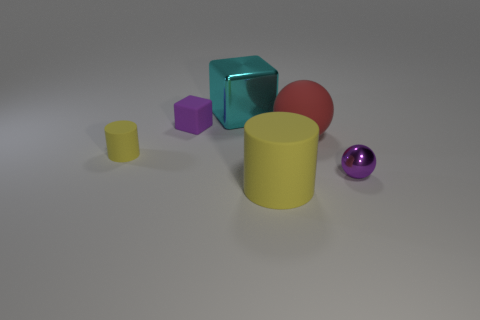Add 2 small cylinders. How many objects exist? 8 Subtract all cubes. How many objects are left? 4 Add 3 rubber cylinders. How many rubber cylinders are left? 5 Add 1 large cubes. How many large cubes exist? 2 Subtract 0 green spheres. How many objects are left? 6 Subtract all metal blocks. Subtract all rubber cylinders. How many objects are left? 3 